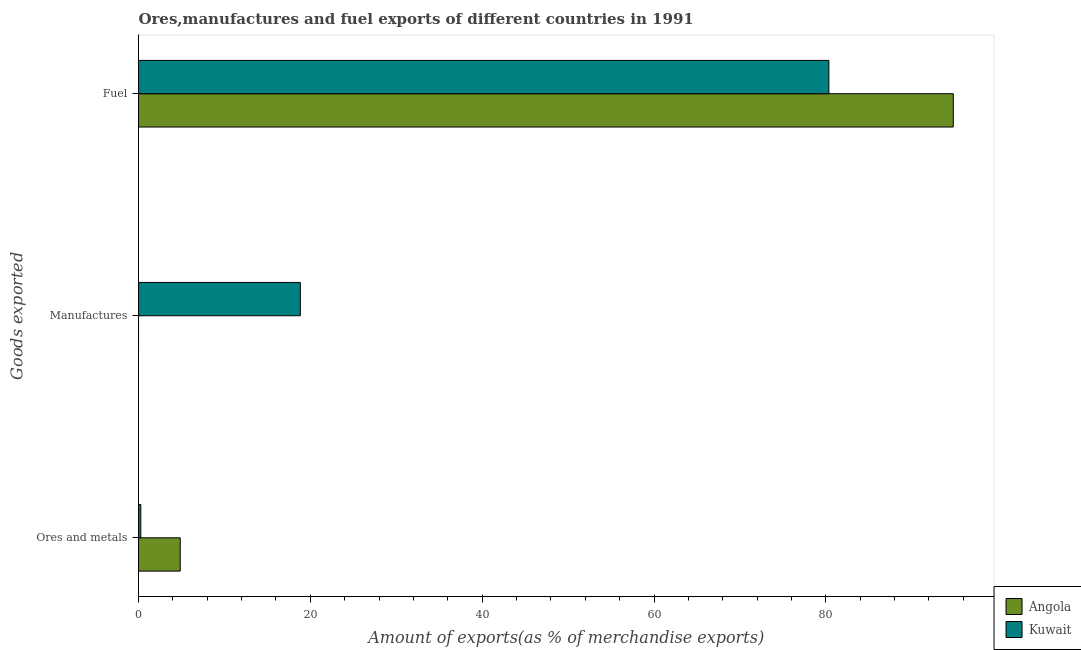How many groups of bars are there?
Provide a succinct answer. 3. Are the number of bars per tick equal to the number of legend labels?
Offer a terse response. Yes. Are the number of bars on each tick of the Y-axis equal?
Your answer should be compact. Yes. How many bars are there on the 3rd tick from the bottom?
Keep it short and to the point. 2. What is the label of the 1st group of bars from the top?
Keep it short and to the point. Fuel. What is the percentage of ores and metals exports in Angola?
Your answer should be compact. 4.86. Across all countries, what is the maximum percentage of fuel exports?
Give a very brief answer. 94.83. Across all countries, what is the minimum percentage of ores and metals exports?
Keep it short and to the point. 0.27. In which country was the percentage of manufactures exports maximum?
Your answer should be very brief. Kuwait. In which country was the percentage of manufactures exports minimum?
Provide a succinct answer. Angola. What is the total percentage of ores and metals exports in the graph?
Ensure brevity in your answer.  5.12. What is the difference between the percentage of fuel exports in Angola and that in Kuwait?
Give a very brief answer. 14.48. What is the difference between the percentage of fuel exports in Kuwait and the percentage of manufactures exports in Angola?
Give a very brief answer. 80.35. What is the average percentage of manufactures exports per country?
Offer a very short reply. 9.42. What is the difference between the percentage of manufactures exports and percentage of ores and metals exports in Angola?
Offer a terse response. -4.85. In how many countries, is the percentage of manufactures exports greater than 64 %?
Ensure brevity in your answer.  0. What is the ratio of the percentage of ores and metals exports in Kuwait to that in Angola?
Your response must be concise. 0.06. Is the percentage of fuel exports in Kuwait less than that in Angola?
Offer a terse response. Yes. Is the difference between the percentage of fuel exports in Angola and Kuwait greater than the difference between the percentage of manufactures exports in Angola and Kuwait?
Provide a succinct answer. Yes. What is the difference between the highest and the second highest percentage of ores and metals exports?
Offer a very short reply. 4.59. What is the difference between the highest and the lowest percentage of fuel exports?
Offer a terse response. 14.48. What does the 1st bar from the top in Fuel represents?
Offer a terse response. Kuwait. What does the 2nd bar from the bottom in Ores and metals represents?
Your answer should be compact. Kuwait. Is it the case that in every country, the sum of the percentage of ores and metals exports and percentage of manufactures exports is greater than the percentage of fuel exports?
Keep it short and to the point. No. Are all the bars in the graph horizontal?
Offer a very short reply. Yes. How many countries are there in the graph?
Ensure brevity in your answer.  2. Does the graph contain grids?
Offer a very short reply. No. How many legend labels are there?
Give a very brief answer. 2. How are the legend labels stacked?
Give a very brief answer. Vertical. What is the title of the graph?
Provide a short and direct response. Ores,manufactures and fuel exports of different countries in 1991. Does "Lower middle income" appear as one of the legend labels in the graph?
Ensure brevity in your answer.  No. What is the label or title of the X-axis?
Keep it short and to the point. Amount of exports(as % of merchandise exports). What is the label or title of the Y-axis?
Keep it short and to the point. Goods exported. What is the Amount of exports(as % of merchandise exports) of Angola in Ores and metals?
Your answer should be compact. 4.86. What is the Amount of exports(as % of merchandise exports) in Kuwait in Ores and metals?
Make the answer very short. 0.27. What is the Amount of exports(as % of merchandise exports) of Angola in Manufactures?
Your answer should be compact. 0. What is the Amount of exports(as % of merchandise exports) of Kuwait in Manufactures?
Keep it short and to the point. 18.84. What is the Amount of exports(as % of merchandise exports) of Angola in Fuel?
Provide a short and direct response. 94.83. What is the Amount of exports(as % of merchandise exports) in Kuwait in Fuel?
Give a very brief answer. 80.36. Across all Goods exported, what is the maximum Amount of exports(as % of merchandise exports) in Angola?
Make the answer very short. 94.83. Across all Goods exported, what is the maximum Amount of exports(as % of merchandise exports) in Kuwait?
Provide a succinct answer. 80.36. Across all Goods exported, what is the minimum Amount of exports(as % of merchandise exports) of Angola?
Ensure brevity in your answer.  0. Across all Goods exported, what is the minimum Amount of exports(as % of merchandise exports) of Kuwait?
Keep it short and to the point. 0.27. What is the total Amount of exports(as % of merchandise exports) of Angola in the graph?
Your answer should be compact. 99.69. What is the total Amount of exports(as % of merchandise exports) in Kuwait in the graph?
Your response must be concise. 99.46. What is the difference between the Amount of exports(as % of merchandise exports) in Angola in Ores and metals and that in Manufactures?
Make the answer very short. 4.85. What is the difference between the Amount of exports(as % of merchandise exports) in Kuwait in Ores and metals and that in Manufactures?
Provide a short and direct response. -18.57. What is the difference between the Amount of exports(as % of merchandise exports) in Angola in Ores and metals and that in Fuel?
Ensure brevity in your answer.  -89.98. What is the difference between the Amount of exports(as % of merchandise exports) of Kuwait in Ores and metals and that in Fuel?
Keep it short and to the point. -80.09. What is the difference between the Amount of exports(as % of merchandise exports) in Angola in Manufactures and that in Fuel?
Ensure brevity in your answer.  -94.83. What is the difference between the Amount of exports(as % of merchandise exports) of Kuwait in Manufactures and that in Fuel?
Provide a succinct answer. -61.52. What is the difference between the Amount of exports(as % of merchandise exports) of Angola in Ores and metals and the Amount of exports(as % of merchandise exports) of Kuwait in Manufactures?
Your response must be concise. -13.98. What is the difference between the Amount of exports(as % of merchandise exports) in Angola in Ores and metals and the Amount of exports(as % of merchandise exports) in Kuwait in Fuel?
Give a very brief answer. -75.5. What is the difference between the Amount of exports(as % of merchandise exports) in Angola in Manufactures and the Amount of exports(as % of merchandise exports) in Kuwait in Fuel?
Keep it short and to the point. -80.35. What is the average Amount of exports(as % of merchandise exports) in Angola per Goods exported?
Provide a short and direct response. 33.23. What is the average Amount of exports(as % of merchandise exports) of Kuwait per Goods exported?
Offer a terse response. 33.15. What is the difference between the Amount of exports(as % of merchandise exports) in Angola and Amount of exports(as % of merchandise exports) in Kuwait in Ores and metals?
Your answer should be compact. 4.59. What is the difference between the Amount of exports(as % of merchandise exports) in Angola and Amount of exports(as % of merchandise exports) in Kuwait in Manufactures?
Provide a short and direct response. -18.83. What is the difference between the Amount of exports(as % of merchandise exports) in Angola and Amount of exports(as % of merchandise exports) in Kuwait in Fuel?
Keep it short and to the point. 14.48. What is the ratio of the Amount of exports(as % of merchandise exports) of Angola in Ores and metals to that in Manufactures?
Give a very brief answer. 2661.17. What is the ratio of the Amount of exports(as % of merchandise exports) of Kuwait in Ores and metals to that in Manufactures?
Provide a short and direct response. 0.01. What is the ratio of the Amount of exports(as % of merchandise exports) of Angola in Ores and metals to that in Fuel?
Ensure brevity in your answer.  0.05. What is the ratio of the Amount of exports(as % of merchandise exports) of Kuwait in Ores and metals to that in Fuel?
Keep it short and to the point. 0. What is the ratio of the Amount of exports(as % of merchandise exports) in Kuwait in Manufactures to that in Fuel?
Offer a terse response. 0.23. What is the difference between the highest and the second highest Amount of exports(as % of merchandise exports) in Angola?
Make the answer very short. 89.98. What is the difference between the highest and the second highest Amount of exports(as % of merchandise exports) in Kuwait?
Your response must be concise. 61.52. What is the difference between the highest and the lowest Amount of exports(as % of merchandise exports) in Angola?
Offer a very short reply. 94.83. What is the difference between the highest and the lowest Amount of exports(as % of merchandise exports) of Kuwait?
Keep it short and to the point. 80.09. 